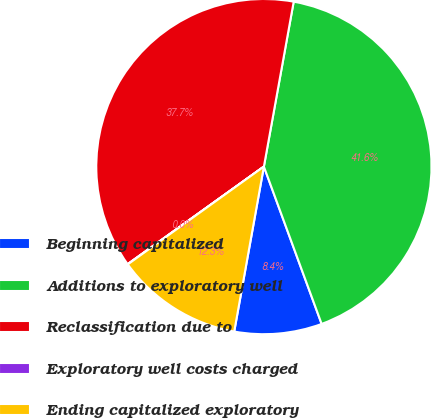<chart> <loc_0><loc_0><loc_500><loc_500><pie_chart><fcel>Beginning capitalized<fcel>Additions to exploratory well<fcel>Reclassification due to<fcel>Exploratory well costs charged<fcel>Ending capitalized exploratory<nl><fcel>8.43%<fcel>41.55%<fcel>37.73%<fcel>0.03%<fcel>12.25%<nl></chart> 